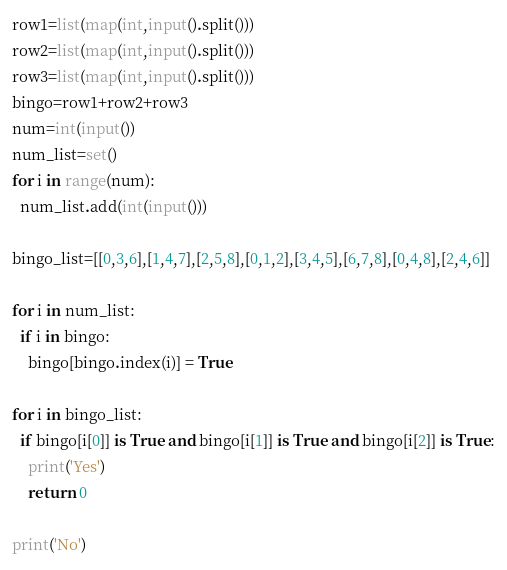<code> <loc_0><loc_0><loc_500><loc_500><_Python_>row1=list(map(int,input().split()))
row2=list(map(int,input().split()))
row3=list(map(int,input().split()))
bingo=row1+row2+row3
num=int(input())
num_list=set()
for i in range(num):
  num_list.add(int(input()))

bingo_list=[[0,3,6],[1,4,7],[2,5,8],[0,1,2],[3,4,5],[6,7,8],[0,4,8],[2,4,6]]
  
for i in num_list:
  if i in bingo:
    bingo[bingo.index(i)] = True

for i in bingo_list:
  if bingo[i[0]] is True and bingo[i[1]] is True and bingo[i[2]] is True:
    print('Yes')
    return 0

print('No')
</code> 